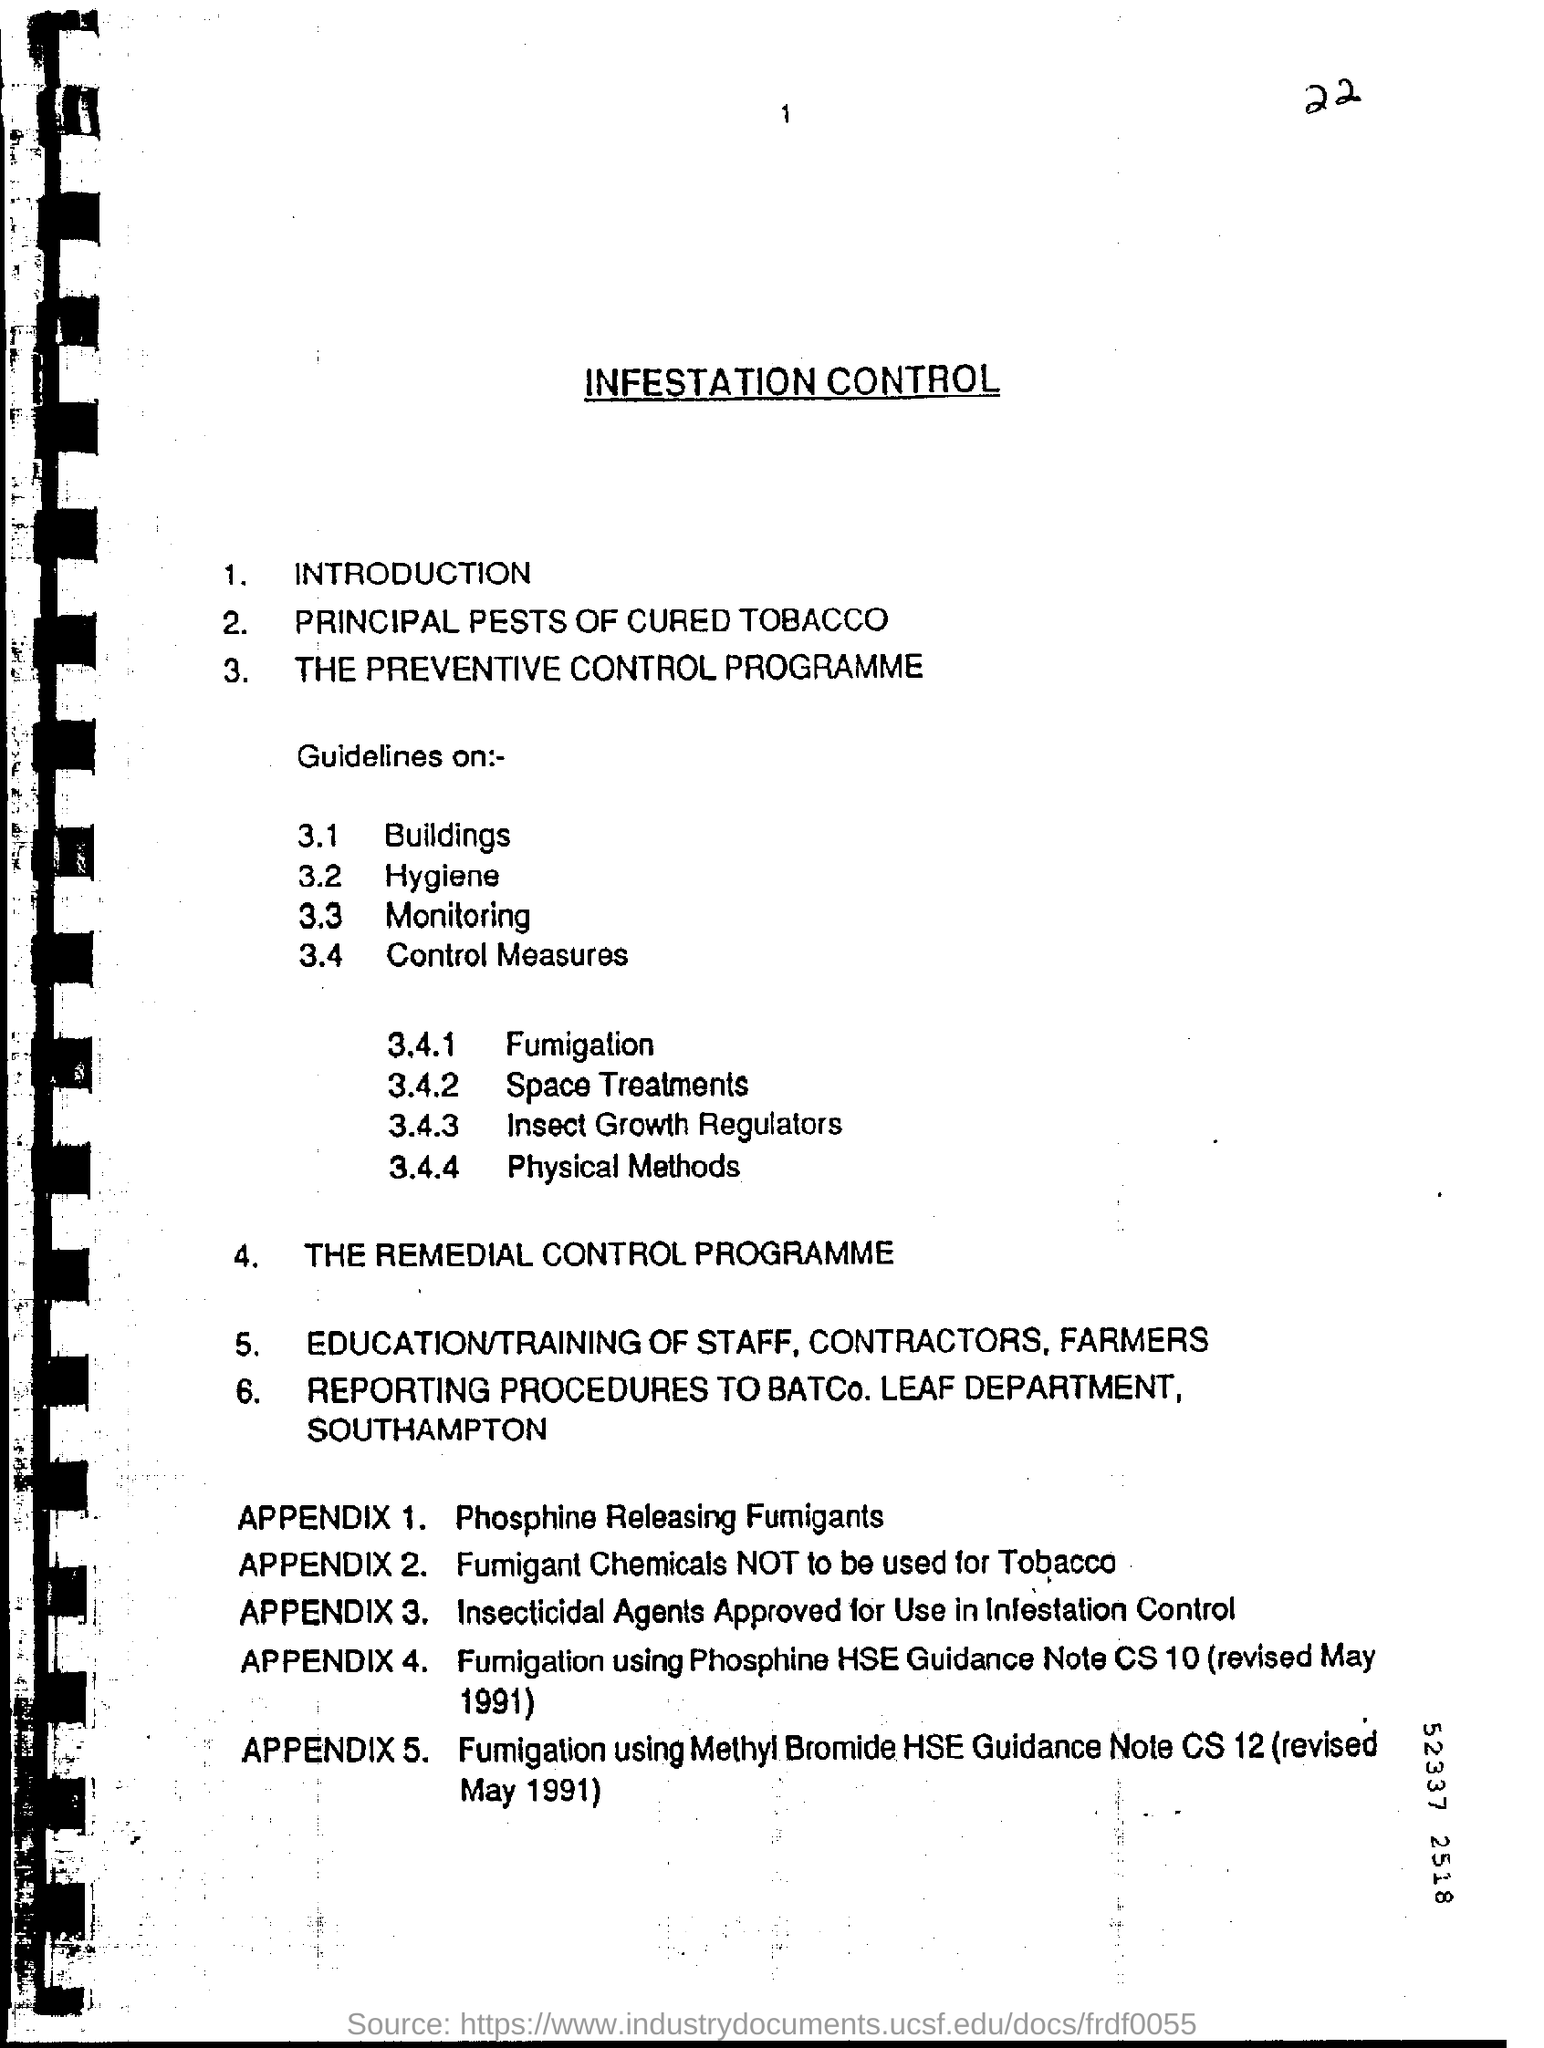What is head line of this document?
Provide a succinct answer. Infestation Control. What is Item no: 2 in this page?
Make the answer very short. Principal Pests of cured Tobacco. What is 3.4.1?
Keep it short and to the point. Fumigation. What is Appendix 1?
Your response must be concise. Phosphine Releasing Fumigants. 